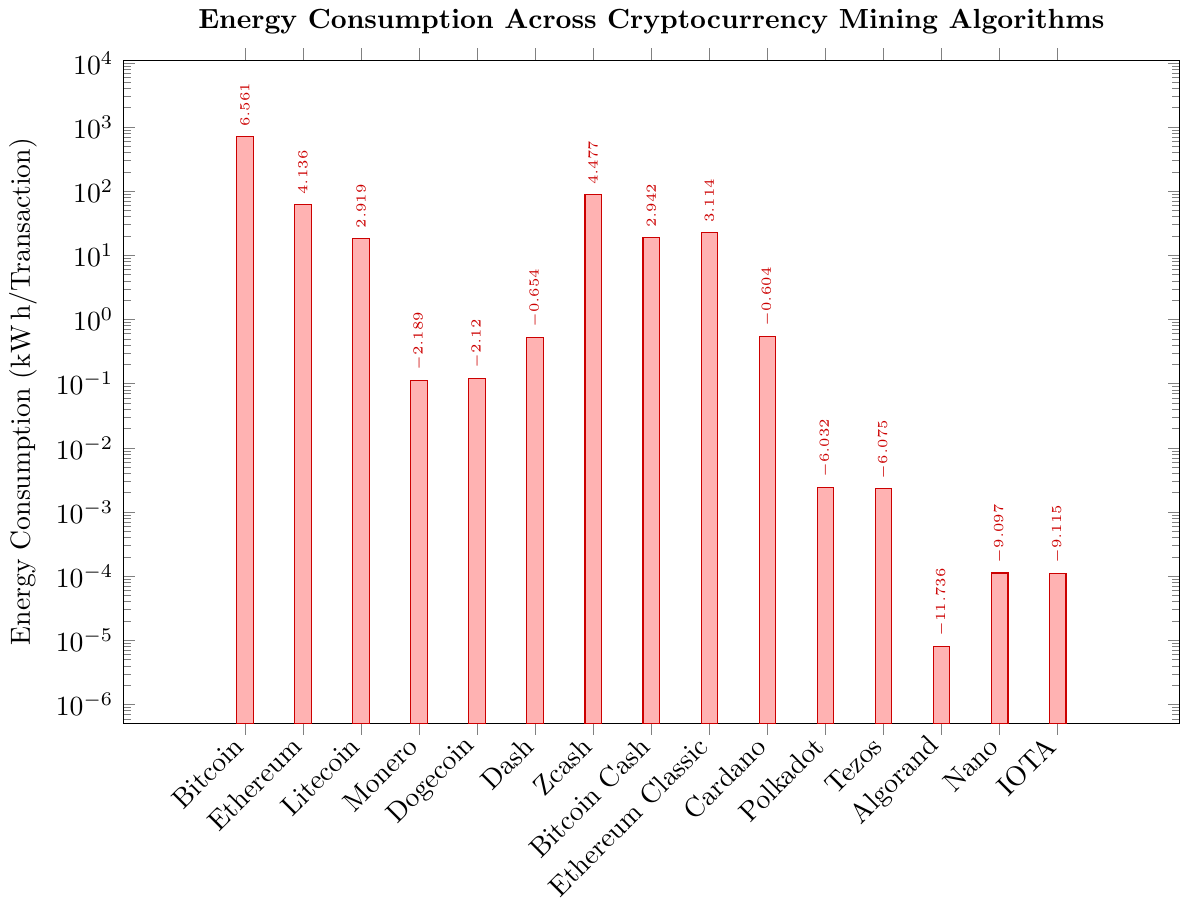Which algorithm has the highest energy consumption? The bar chart shows the height of each bar representing energy consumption. The tallest bar is for Bitcoin (SHA-256) at 707 kWh/Transaction.
Answer: Bitcoin (SHA-256) Which algorithm has the lowest energy consumption? The shortest bar in the chart represents Algorand (Pure PoS), showing the smallest value which is 0.000008 kWh/Transaction.
Answer: Algorand (Pure PoS) What is the difference in energy consumption between Bitcoin and Ethereum? Bitcoin has an energy consumption of 707 kWh/Transaction and Ethereum has 62.56 kWh/Transaction. The difference is calculated as 707 - 62.56 = 644.44 kWh/Transaction.
Answer: 644.44 kWh/Transaction What is the total energy consumption for Bitcoin, Litecoin, and Dash combined? Add the energy consumption for Bitcoin (707), Litecoin (18.52), and Dash (0.52): 707 + 18.52 + 0.52 = 726.04 kWh/Transaction.
Answer: 726.04 kWh/Transaction Which algorithm consumes less energy: Monero or Dogecoin? From the chart, Monero's bar shows 0.112 kWh/Transaction, whereas Dogecoin's bar shows 0.12 kWh/Transaction. Monero consumes less energy.
Answer: Monero How does the energy consumption of Zcash compare to Ethereum Classic? The bar for Zcash shows it consumes 88 kWh/Transaction, while Ethereum Classic consumes 22.5 kWh/Transaction. Zcash consumes more energy than Ethereum Classic.
Answer: Zcash Which algorithms have energy consumption values below 1 kWh/Transaction and above 0.1 kWh/Transaction? Monero (0.112), Dogecoin (0.12), Dash (0.52), and Cardano (0.5467) are the bars that fall within this range.
Answer: Monero, Dogecoin, Dash, Cardano What is the average energy consumption for Ethereum, Litecoin, and Bitcoin Cash? Add the consumption for Ethereum (62.56), Litecoin (18.52), and Bitcoin Cash (18.95) and divide by 3: (62.56 + 18.52 + 18.95) / 3 = 33.3433 kWh/Transaction.
Answer: 33.3433 kWh/Transaction Among the algorithms with energy consumption less than 1 kWh/Transaction, which one is the highest? The highest value bar below 1 kWh/Transaction is Cardano, with 0.5467 kWh/Transaction.
Answer: Cardano 